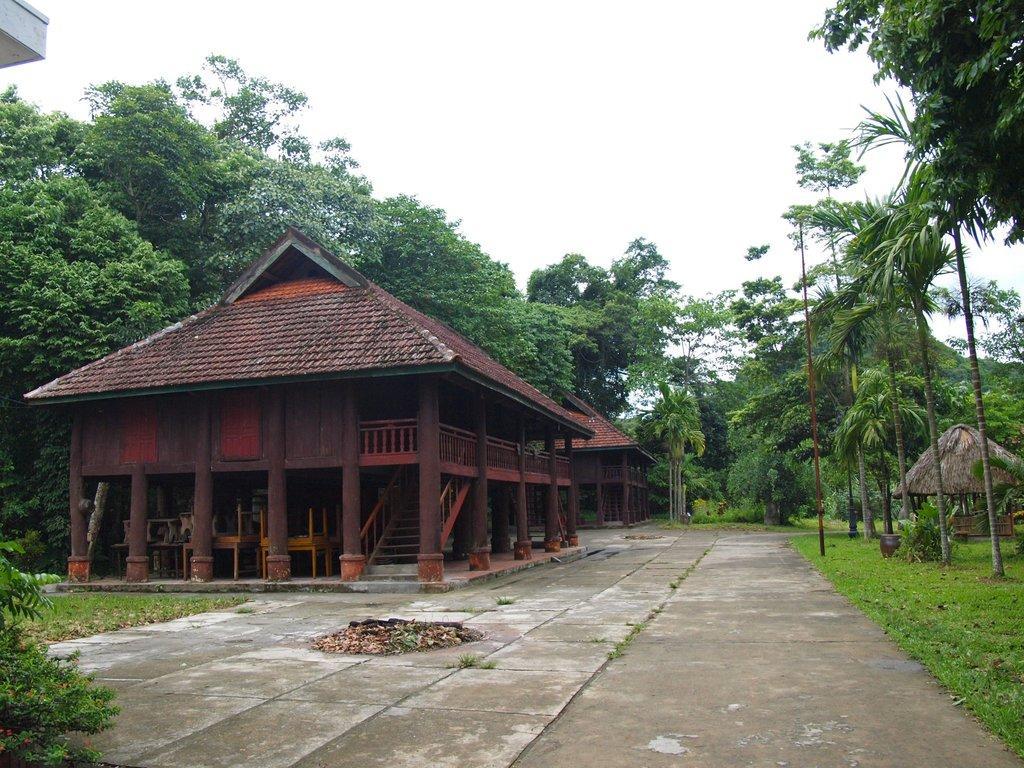Please provide a concise description of this image. On the left side of the image we can see the houses, stairs, railing, roofs, chairs. On the right side of the image we can see a hot, pot, pole. In the background of the image we can see the trees, grass. At the bottom of the image we can see the floor. At the top of the image we can see the sky. 